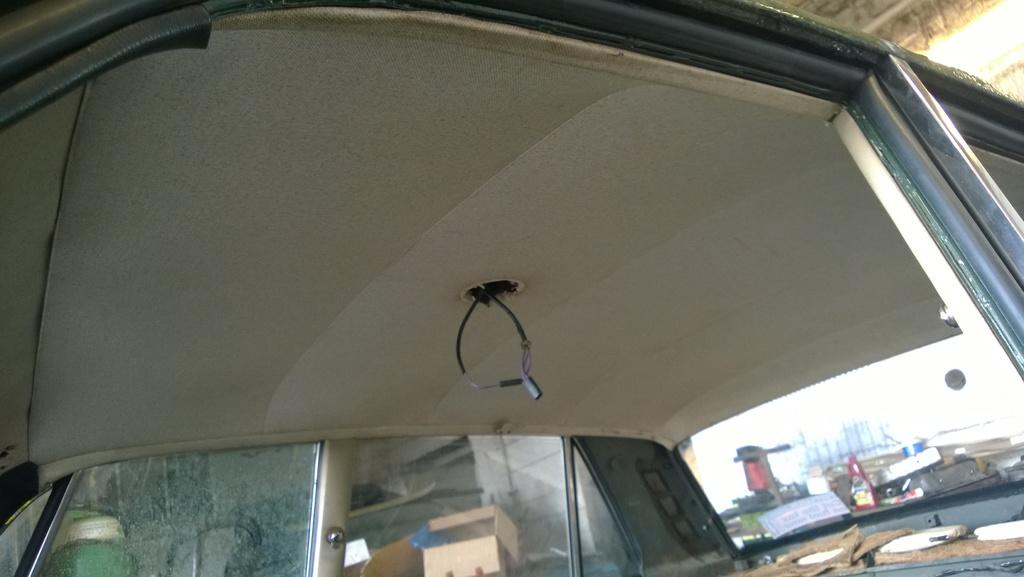What type of setting is depicted in the image? The image is an inside view of a vehicle. What feature allows for visibility outside the vehicle? There is a window in the vehicle. What can be seen through the window in the image? Other objects are visible through the window. What type of bedroom furniture can be seen through the window in the image? There is no bedroom furniture visible through the window in the image, as it is an inside view of a vehicle. 